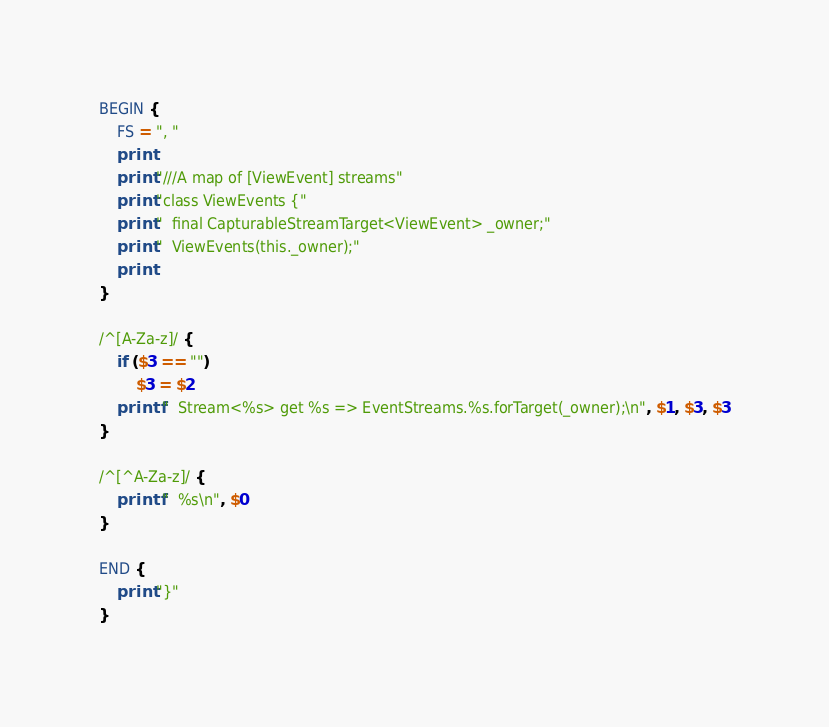Convert code to text. <code><loc_0><loc_0><loc_500><loc_500><_Awk_>BEGIN {
	FS = ", "
	print
	print "///A map of [ViewEvent] streams"
	print "class ViewEvents {"
	print "  final CapturableStreamTarget<ViewEvent> _owner;"
	print "  ViewEvents(this._owner);"
	print
}

/^[A-Za-z]/ {
	if ($3 == "")
		$3 = $2
	printf "  Stream<%s> get %s => EventStreams.%s.forTarget(_owner);\n", $1, $3, $3
}

/^[^A-Za-z]/ {
	printf "  %s\n", $0
}

END {
	print "}"
}
</code> 